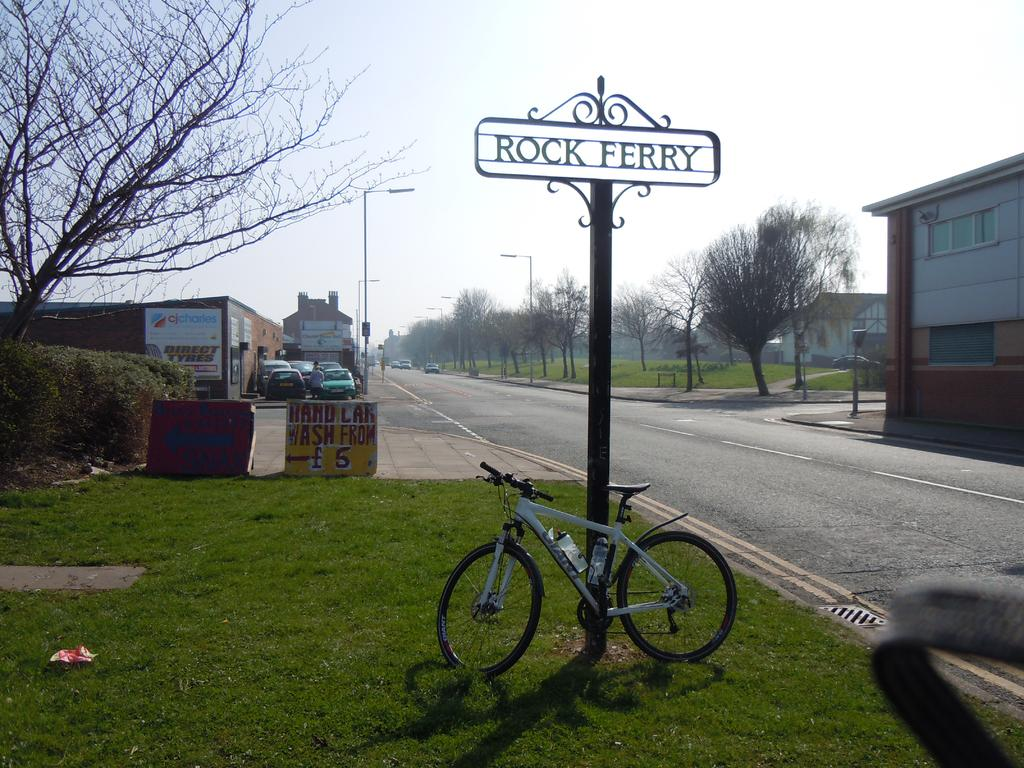What type of structures can be seen in the image? There are buildings in the image. What is happening on the road in the image? Vehicles are moving on the road can be seen in the image. Where is the bicycle located in the image? The bicycle is placed on the grass in the image. What object can be seen standing upright in the image? There is a pole in the image. What type of cabbage is growing on the pole in the image? There is no cabbage present in the image, and the pole is not a plant-growing structure. Can you see any blood on the bicycle in the image? There is no blood visible on the bicycle or anywhere else in the image. 